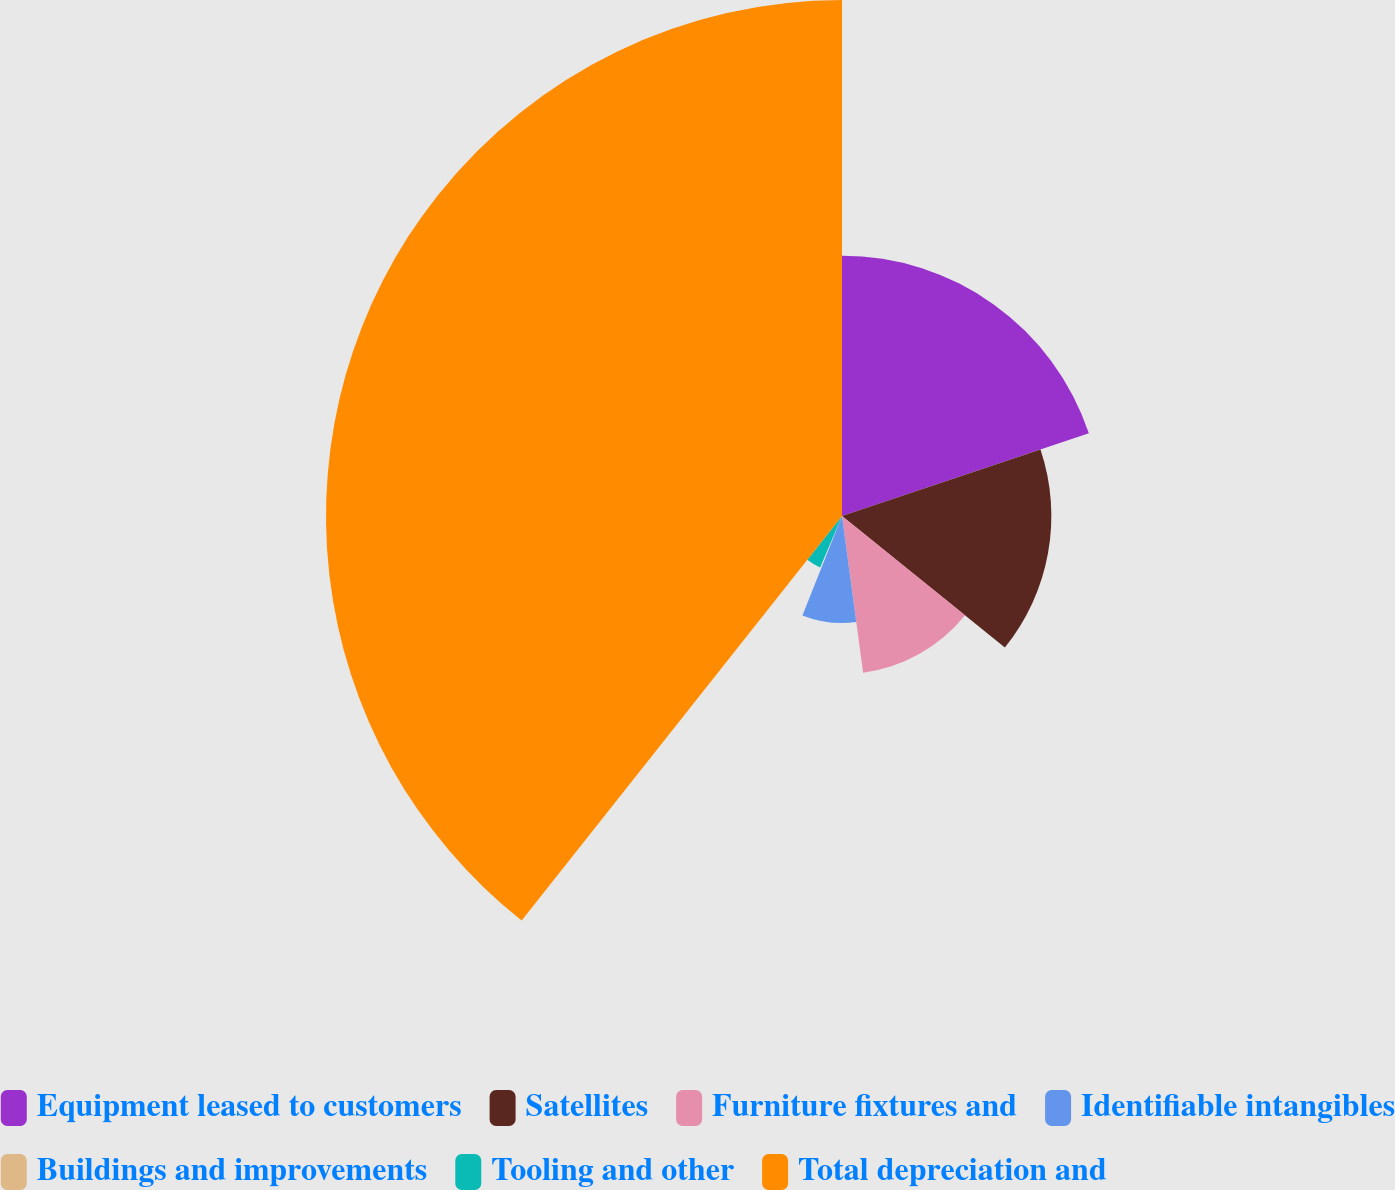Convert chart to OTSL. <chart><loc_0><loc_0><loc_500><loc_500><pie_chart><fcel>Equipment leased to customers<fcel>Satellites<fcel>Furniture fixtures and<fcel>Identifiable intangibles<fcel>Buildings and improvements<fcel>Tooling and other<fcel>Total depreciation and<nl><fcel>19.85%<fcel>15.96%<fcel>12.06%<fcel>8.16%<fcel>0.37%<fcel>4.26%<fcel>39.34%<nl></chart> 